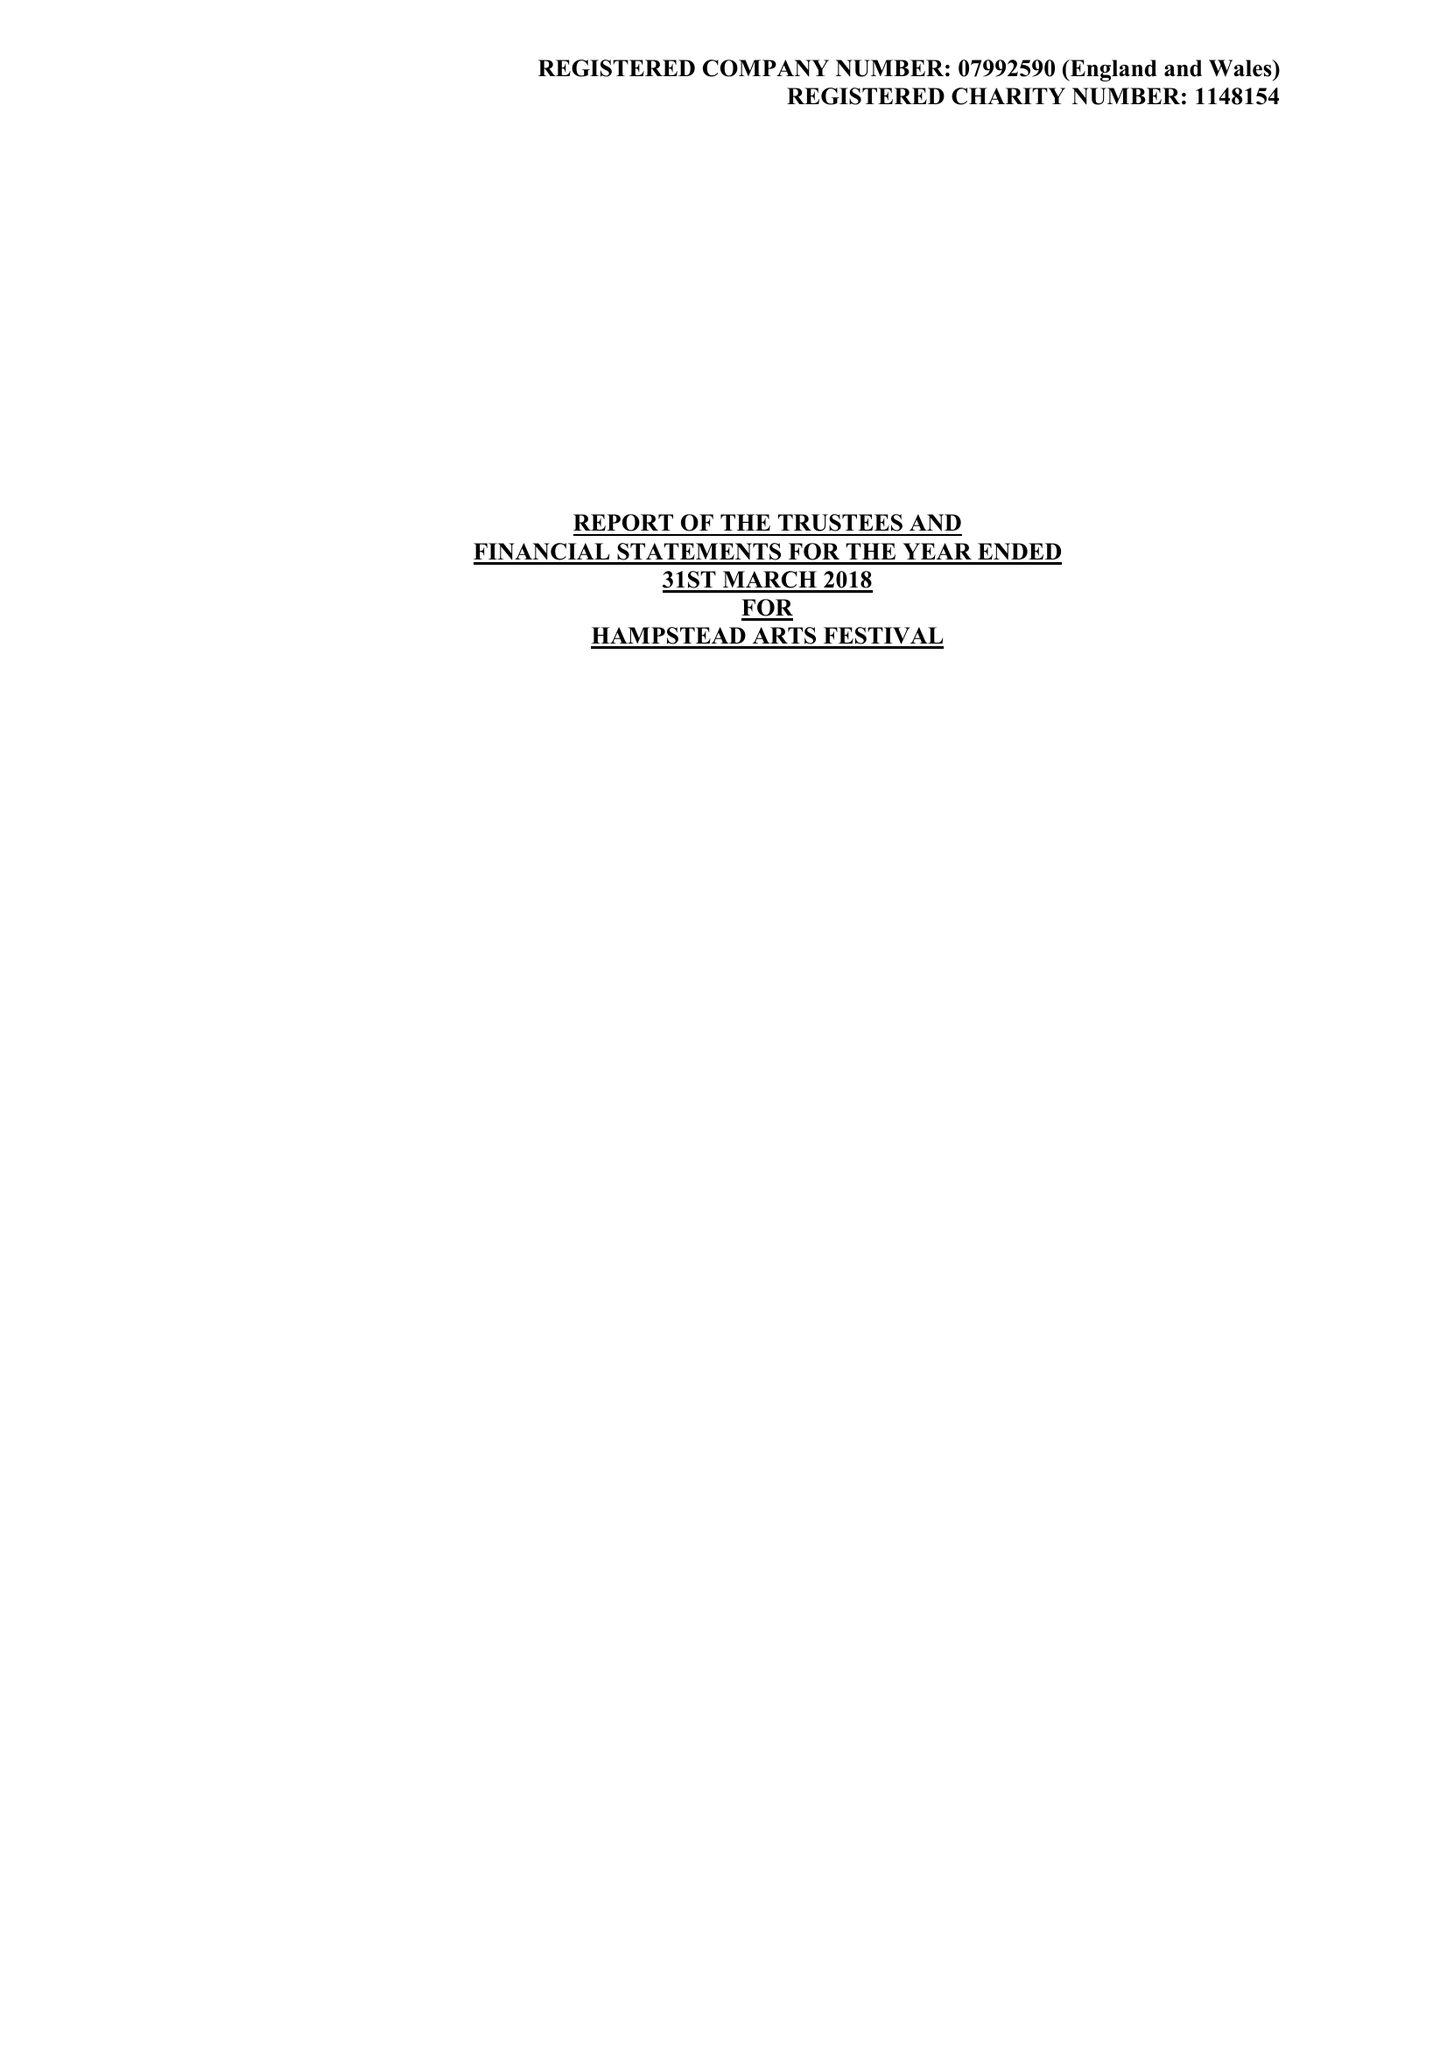What is the value for the address__post_town?
Answer the question using a single word or phrase. HARROW 